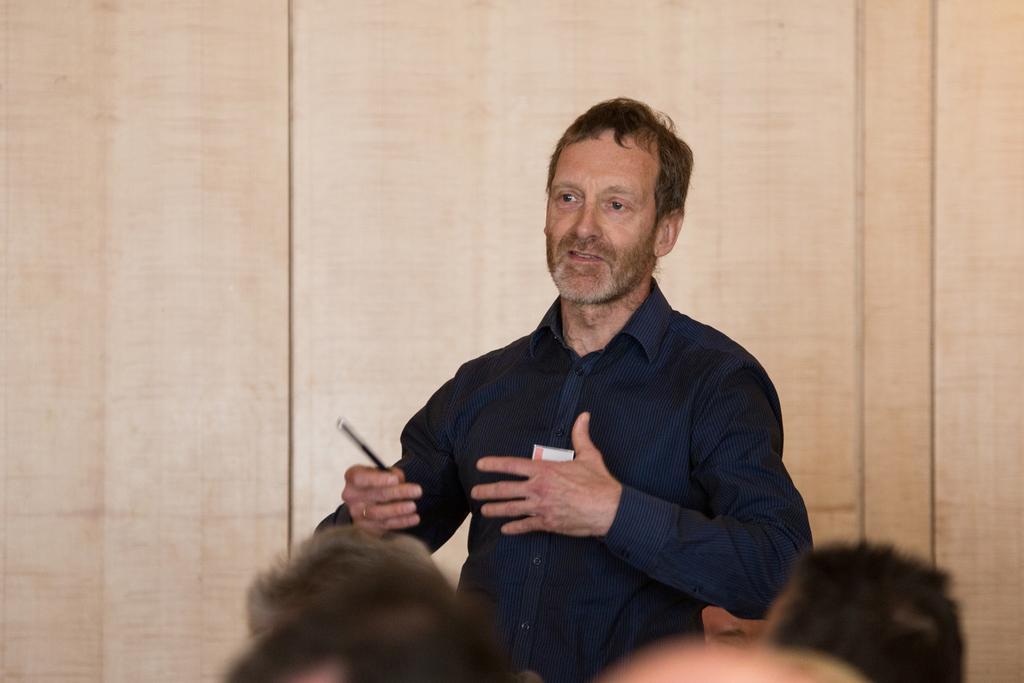In one or two sentences, can you explain what this image depicts? In the center of the image a man is standing and holding a pen. In the background of the image wall is present. At the bottom of the image some persons are there. 